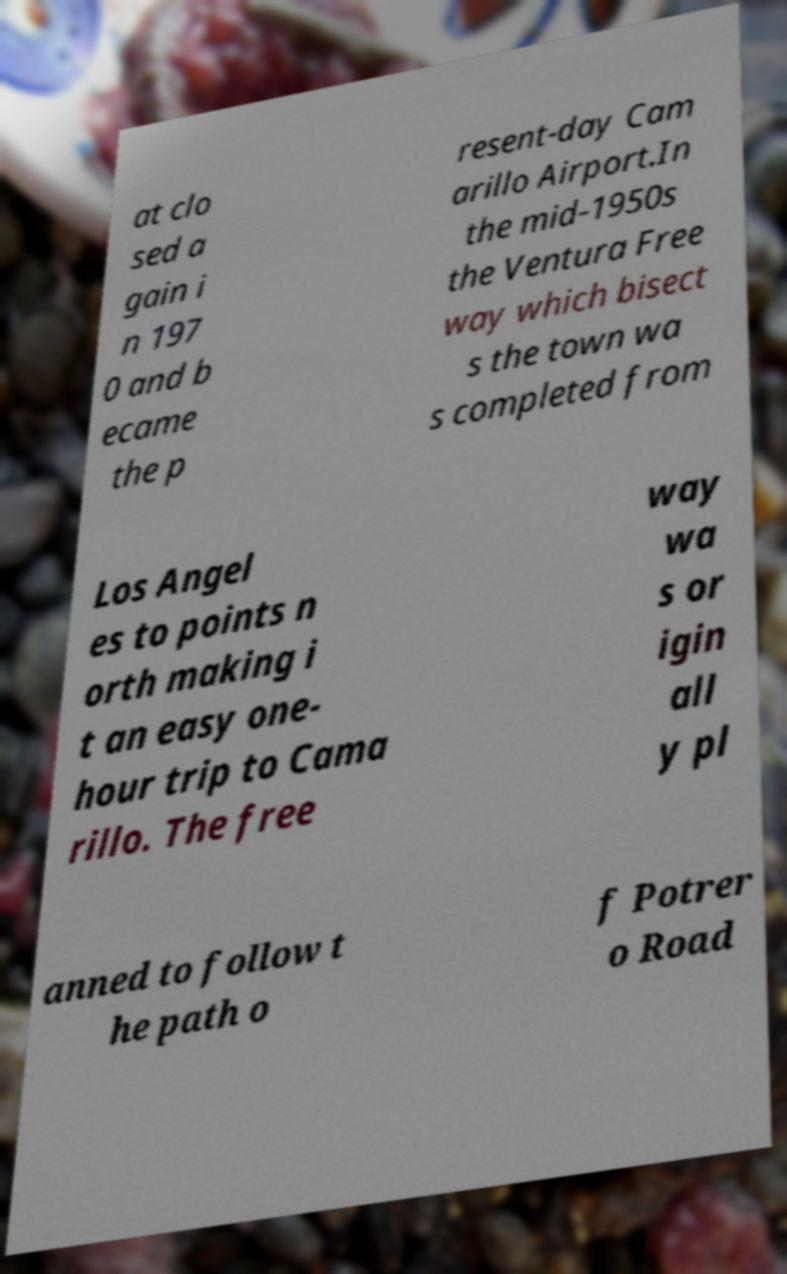I need the written content from this picture converted into text. Can you do that? at clo sed a gain i n 197 0 and b ecame the p resent-day Cam arillo Airport.In the mid-1950s the Ventura Free way which bisect s the town wa s completed from Los Angel es to points n orth making i t an easy one- hour trip to Cama rillo. The free way wa s or igin all y pl anned to follow t he path o f Potrer o Road 